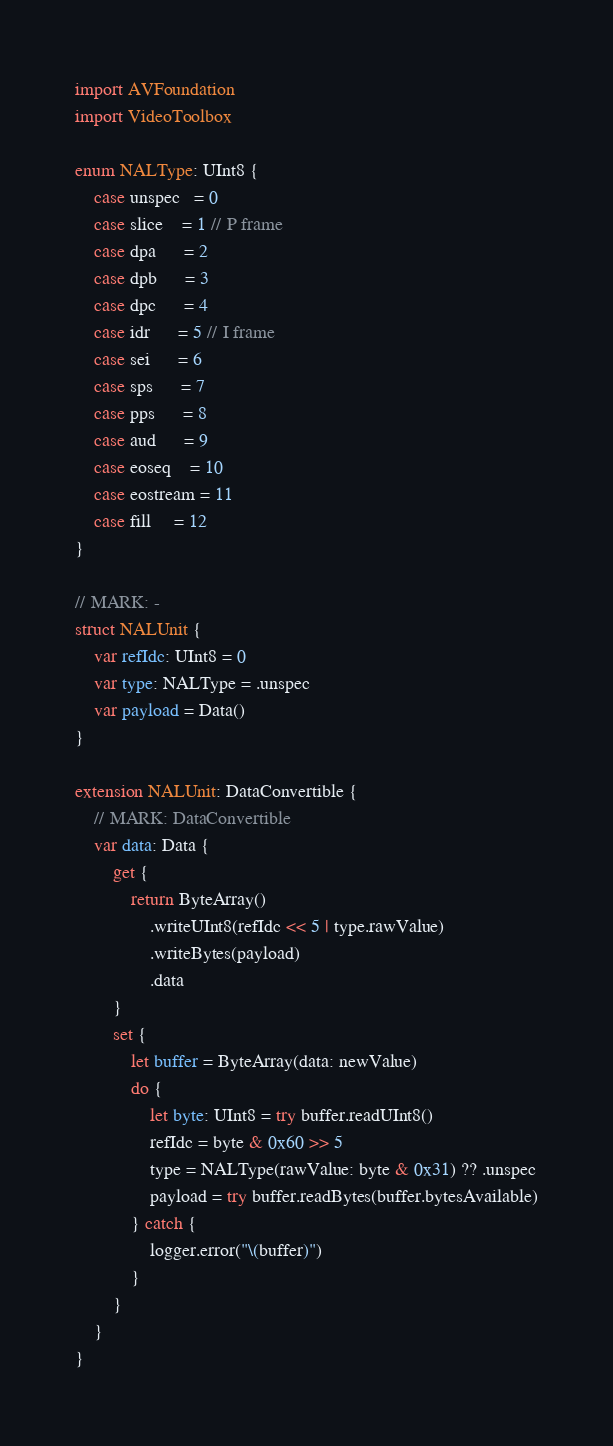<code> <loc_0><loc_0><loc_500><loc_500><_Swift_>import AVFoundation
import VideoToolbox

enum NALType: UInt8 {
    case unspec   = 0
    case slice    = 1 // P frame
    case dpa      = 2
    case dpb      = 3
    case dpc      = 4
    case idr      = 5 // I frame
    case sei      = 6
    case sps      = 7
    case pps      = 8
    case aud      = 9
    case eoseq    = 10
    case eostream = 11
    case fill     = 12
}

// MARK: -
struct NALUnit {
    var refIdc: UInt8 = 0
    var type: NALType = .unspec
    var payload = Data()
}

extension NALUnit: DataConvertible {
    // MARK: DataConvertible
    var data: Data {
        get {
            return ByteArray()
                .writeUInt8(refIdc << 5 | type.rawValue)
                .writeBytes(payload)
                .data
        }
        set {
            let buffer = ByteArray(data: newValue)
            do {
                let byte: UInt8 = try buffer.readUInt8()
                refIdc = byte & 0x60 >> 5
                type = NALType(rawValue: byte & 0x31) ?? .unspec
                payload = try buffer.readBytes(buffer.bytesAvailable)
            } catch {
                logger.error("\(buffer)")
            }
        }
    }
}
</code> 